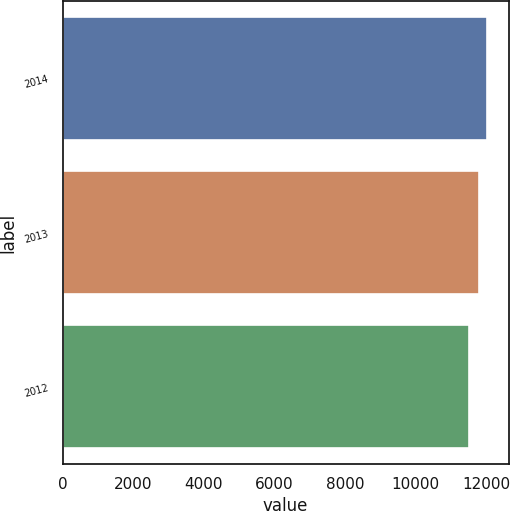Convert chart to OTSL. <chart><loc_0><loc_0><loc_500><loc_500><bar_chart><fcel>2014<fcel>2013<fcel>2012<nl><fcel>12045<fcel>11815<fcel>11514<nl></chart> 